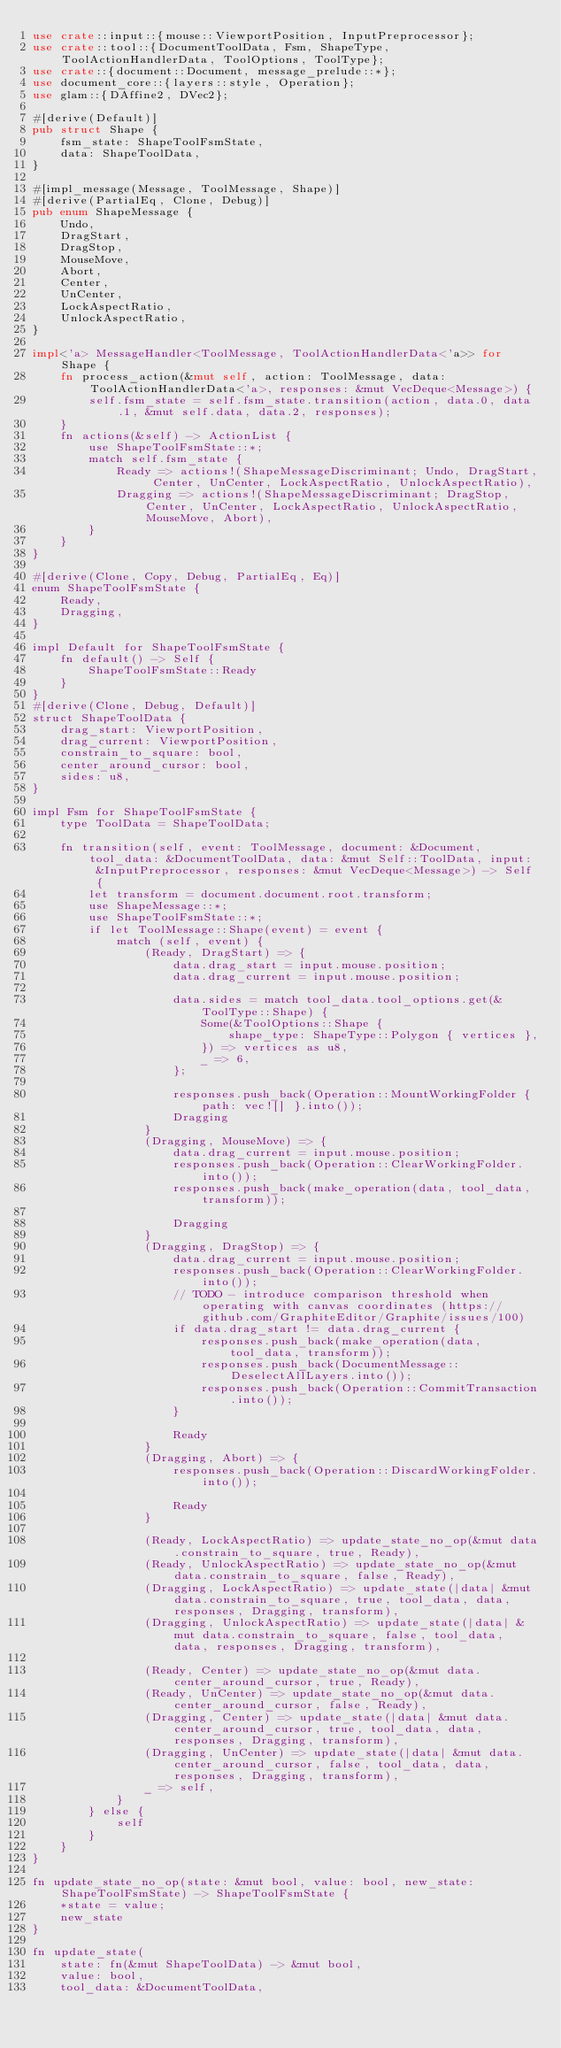Convert code to text. <code><loc_0><loc_0><loc_500><loc_500><_Rust_>use crate::input::{mouse::ViewportPosition, InputPreprocessor};
use crate::tool::{DocumentToolData, Fsm, ShapeType, ToolActionHandlerData, ToolOptions, ToolType};
use crate::{document::Document, message_prelude::*};
use document_core::{layers::style, Operation};
use glam::{DAffine2, DVec2};

#[derive(Default)]
pub struct Shape {
	fsm_state: ShapeToolFsmState,
	data: ShapeToolData,
}

#[impl_message(Message, ToolMessage, Shape)]
#[derive(PartialEq, Clone, Debug)]
pub enum ShapeMessage {
	Undo,
	DragStart,
	DragStop,
	MouseMove,
	Abort,
	Center,
	UnCenter,
	LockAspectRatio,
	UnlockAspectRatio,
}

impl<'a> MessageHandler<ToolMessage, ToolActionHandlerData<'a>> for Shape {
	fn process_action(&mut self, action: ToolMessage, data: ToolActionHandlerData<'a>, responses: &mut VecDeque<Message>) {
		self.fsm_state = self.fsm_state.transition(action, data.0, data.1, &mut self.data, data.2, responses);
	}
	fn actions(&self) -> ActionList {
		use ShapeToolFsmState::*;
		match self.fsm_state {
			Ready => actions!(ShapeMessageDiscriminant; Undo, DragStart, Center, UnCenter, LockAspectRatio, UnlockAspectRatio),
			Dragging => actions!(ShapeMessageDiscriminant; DragStop, Center, UnCenter, LockAspectRatio, UnlockAspectRatio, MouseMove, Abort),
		}
	}
}

#[derive(Clone, Copy, Debug, PartialEq, Eq)]
enum ShapeToolFsmState {
	Ready,
	Dragging,
}

impl Default for ShapeToolFsmState {
	fn default() -> Self {
		ShapeToolFsmState::Ready
	}
}
#[derive(Clone, Debug, Default)]
struct ShapeToolData {
	drag_start: ViewportPosition,
	drag_current: ViewportPosition,
	constrain_to_square: bool,
	center_around_cursor: bool,
	sides: u8,
}

impl Fsm for ShapeToolFsmState {
	type ToolData = ShapeToolData;

	fn transition(self, event: ToolMessage, document: &Document, tool_data: &DocumentToolData, data: &mut Self::ToolData, input: &InputPreprocessor, responses: &mut VecDeque<Message>) -> Self {
		let transform = document.document.root.transform;
		use ShapeMessage::*;
		use ShapeToolFsmState::*;
		if let ToolMessage::Shape(event) = event {
			match (self, event) {
				(Ready, DragStart) => {
					data.drag_start = input.mouse.position;
					data.drag_current = input.mouse.position;

					data.sides = match tool_data.tool_options.get(&ToolType::Shape) {
						Some(&ToolOptions::Shape {
							shape_type: ShapeType::Polygon { vertices },
						}) => vertices as u8,
						_ => 6,
					};

					responses.push_back(Operation::MountWorkingFolder { path: vec![] }.into());
					Dragging
				}
				(Dragging, MouseMove) => {
					data.drag_current = input.mouse.position;
					responses.push_back(Operation::ClearWorkingFolder.into());
					responses.push_back(make_operation(data, tool_data, transform));

					Dragging
				}
				(Dragging, DragStop) => {
					data.drag_current = input.mouse.position;
					responses.push_back(Operation::ClearWorkingFolder.into());
					// TODO - introduce comparison threshold when operating with canvas coordinates (https://github.com/GraphiteEditor/Graphite/issues/100)
					if data.drag_start != data.drag_current {
						responses.push_back(make_operation(data, tool_data, transform));
						responses.push_back(DocumentMessage::DeselectAllLayers.into());
						responses.push_back(Operation::CommitTransaction.into());
					}

					Ready
				}
				(Dragging, Abort) => {
					responses.push_back(Operation::DiscardWorkingFolder.into());

					Ready
				}

				(Ready, LockAspectRatio) => update_state_no_op(&mut data.constrain_to_square, true, Ready),
				(Ready, UnlockAspectRatio) => update_state_no_op(&mut data.constrain_to_square, false, Ready),
				(Dragging, LockAspectRatio) => update_state(|data| &mut data.constrain_to_square, true, tool_data, data, responses, Dragging, transform),
				(Dragging, UnlockAspectRatio) => update_state(|data| &mut data.constrain_to_square, false, tool_data, data, responses, Dragging, transform),

				(Ready, Center) => update_state_no_op(&mut data.center_around_cursor, true, Ready),
				(Ready, UnCenter) => update_state_no_op(&mut data.center_around_cursor, false, Ready),
				(Dragging, Center) => update_state(|data| &mut data.center_around_cursor, true, tool_data, data, responses, Dragging, transform),
				(Dragging, UnCenter) => update_state(|data| &mut data.center_around_cursor, false, tool_data, data, responses, Dragging, transform),
				_ => self,
			}
		} else {
			self
		}
	}
}

fn update_state_no_op(state: &mut bool, value: bool, new_state: ShapeToolFsmState) -> ShapeToolFsmState {
	*state = value;
	new_state
}

fn update_state(
	state: fn(&mut ShapeToolData) -> &mut bool,
	value: bool,
	tool_data: &DocumentToolData,</code> 